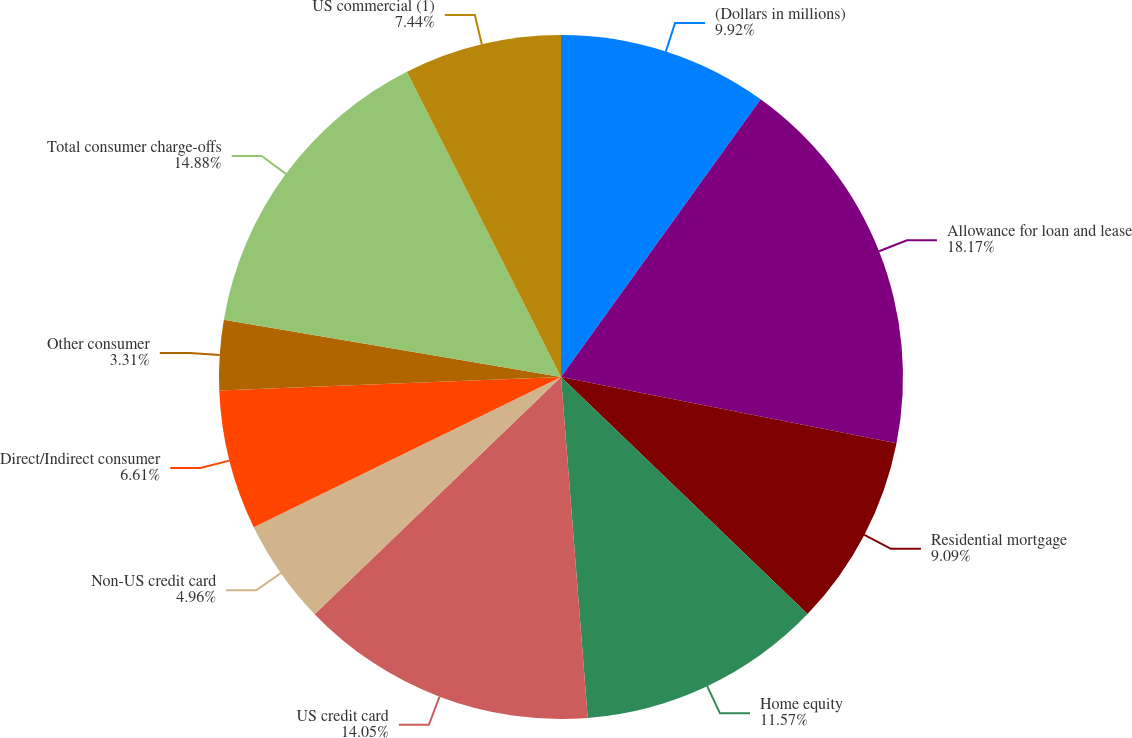<chart> <loc_0><loc_0><loc_500><loc_500><pie_chart><fcel>(Dollars in millions)<fcel>Allowance for loan and lease<fcel>Residential mortgage<fcel>Home equity<fcel>US credit card<fcel>Non-US credit card<fcel>Direct/Indirect consumer<fcel>Other consumer<fcel>Total consumer charge-offs<fcel>US commercial (1)<nl><fcel>9.92%<fcel>18.18%<fcel>9.09%<fcel>11.57%<fcel>14.05%<fcel>4.96%<fcel>6.61%<fcel>3.31%<fcel>14.88%<fcel>7.44%<nl></chart> 